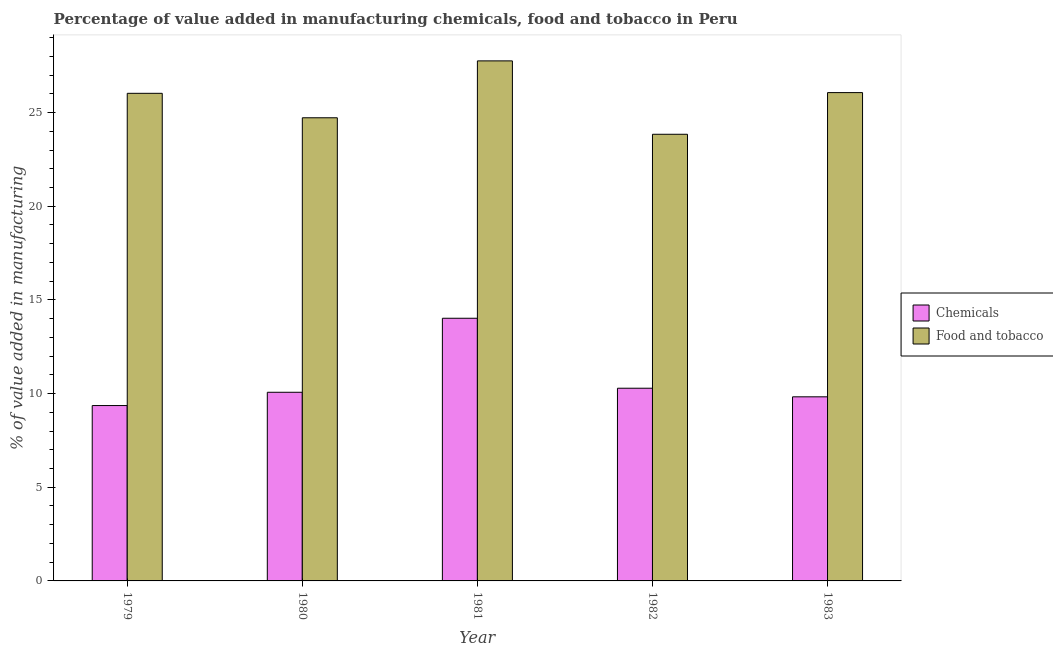How many different coloured bars are there?
Offer a very short reply. 2. How many groups of bars are there?
Offer a terse response. 5. Are the number of bars per tick equal to the number of legend labels?
Your answer should be very brief. Yes. How many bars are there on the 4th tick from the left?
Ensure brevity in your answer.  2. How many bars are there on the 5th tick from the right?
Offer a very short reply. 2. In how many cases, is the number of bars for a given year not equal to the number of legend labels?
Make the answer very short. 0. What is the value added by manufacturing food and tobacco in 1982?
Provide a short and direct response. 23.84. Across all years, what is the maximum value added by manufacturing food and tobacco?
Provide a short and direct response. 27.76. Across all years, what is the minimum value added by manufacturing food and tobacco?
Keep it short and to the point. 23.84. In which year was the value added by  manufacturing chemicals maximum?
Your answer should be compact. 1981. In which year was the value added by  manufacturing chemicals minimum?
Your answer should be compact. 1979. What is the total value added by manufacturing food and tobacco in the graph?
Keep it short and to the point. 128.42. What is the difference between the value added by manufacturing food and tobacco in 1980 and that in 1982?
Provide a short and direct response. 0.88. What is the difference between the value added by  manufacturing chemicals in 1982 and the value added by manufacturing food and tobacco in 1980?
Provide a succinct answer. 0.22. What is the average value added by manufacturing food and tobacco per year?
Ensure brevity in your answer.  25.68. In the year 1982, what is the difference between the value added by manufacturing food and tobacco and value added by  manufacturing chemicals?
Make the answer very short. 0. What is the ratio of the value added by manufacturing food and tobacco in 1979 to that in 1981?
Make the answer very short. 0.94. Is the value added by manufacturing food and tobacco in 1982 less than that in 1983?
Give a very brief answer. Yes. Is the difference between the value added by manufacturing food and tobacco in 1980 and 1981 greater than the difference between the value added by  manufacturing chemicals in 1980 and 1981?
Your answer should be compact. No. What is the difference between the highest and the second highest value added by  manufacturing chemicals?
Your response must be concise. 3.73. What is the difference between the highest and the lowest value added by  manufacturing chemicals?
Offer a terse response. 4.66. In how many years, is the value added by  manufacturing chemicals greater than the average value added by  manufacturing chemicals taken over all years?
Your answer should be very brief. 1. What does the 2nd bar from the left in 1981 represents?
Provide a succinct answer. Food and tobacco. What does the 1st bar from the right in 1981 represents?
Offer a very short reply. Food and tobacco. How many bars are there?
Give a very brief answer. 10. How many years are there in the graph?
Make the answer very short. 5. Are the values on the major ticks of Y-axis written in scientific E-notation?
Offer a terse response. No. Does the graph contain any zero values?
Provide a succinct answer. No. Where does the legend appear in the graph?
Your answer should be compact. Center right. How many legend labels are there?
Offer a terse response. 2. How are the legend labels stacked?
Offer a very short reply. Vertical. What is the title of the graph?
Give a very brief answer. Percentage of value added in manufacturing chemicals, food and tobacco in Peru. What is the label or title of the Y-axis?
Provide a succinct answer. % of value added in manufacturing. What is the % of value added in manufacturing in Chemicals in 1979?
Your answer should be compact. 9.36. What is the % of value added in manufacturing in Food and tobacco in 1979?
Ensure brevity in your answer.  26.03. What is the % of value added in manufacturing in Chemicals in 1980?
Your answer should be very brief. 10.07. What is the % of value added in manufacturing in Food and tobacco in 1980?
Keep it short and to the point. 24.72. What is the % of value added in manufacturing in Chemicals in 1981?
Make the answer very short. 14.02. What is the % of value added in manufacturing of Food and tobacco in 1981?
Your answer should be compact. 27.76. What is the % of value added in manufacturing in Chemicals in 1982?
Keep it short and to the point. 10.29. What is the % of value added in manufacturing of Food and tobacco in 1982?
Provide a short and direct response. 23.84. What is the % of value added in manufacturing in Chemicals in 1983?
Offer a very short reply. 9.83. What is the % of value added in manufacturing in Food and tobacco in 1983?
Provide a succinct answer. 26.07. Across all years, what is the maximum % of value added in manufacturing in Chemicals?
Ensure brevity in your answer.  14.02. Across all years, what is the maximum % of value added in manufacturing in Food and tobacco?
Offer a very short reply. 27.76. Across all years, what is the minimum % of value added in manufacturing in Chemicals?
Offer a very short reply. 9.36. Across all years, what is the minimum % of value added in manufacturing in Food and tobacco?
Your answer should be compact. 23.84. What is the total % of value added in manufacturing of Chemicals in the graph?
Provide a short and direct response. 53.56. What is the total % of value added in manufacturing of Food and tobacco in the graph?
Keep it short and to the point. 128.42. What is the difference between the % of value added in manufacturing in Chemicals in 1979 and that in 1980?
Offer a very short reply. -0.71. What is the difference between the % of value added in manufacturing of Food and tobacco in 1979 and that in 1980?
Give a very brief answer. 1.31. What is the difference between the % of value added in manufacturing of Chemicals in 1979 and that in 1981?
Ensure brevity in your answer.  -4.66. What is the difference between the % of value added in manufacturing in Food and tobacco in 1979 and that in 1981?
Provide a short and direct response. -1.73. What is the difference between the % of value added in manufacturing of Chemicals in 1979 and that in 1982?
Provide a short and direct response. -0.93. What is the difference between the % of value added in manufacturing in Food and tobacco in 1979 and that in 1982?
Give a very brief answer. 2.19. What is the difference between the % of value added in manufacturing in Chemicals in 1979 and that in 1983?
Your answer should be very brief. -0.47. What is the difference between the % of value added in manufacturing in Food and tobacco in 1979 and that in 1983?
Your answer should be compact. -0.04. What is the difference between the % of value added in manufacturing of Chemicals in 1980 and that in 1981?
Ensure brevity in your answer.  -3.95. What is the difference between the % of value added in manufacturing in Food and tobacco in 1980 and that in 1981?
Provide a short and direct response. -3.04. What is the difference between the % of value added in manufacturing of Chemicals in 1980 and that in 1982?
Your answer should be compact. -0.22. What is the difference between the % of value added in manufacturing in Food and tobacco in 1980 and that in 1982?
Provide a succinct answer. 0.88. What is the difference between the % of value added in manufacturing of Chemicals in 1980 and that in 1983?
Offer a terse response. 0.24. What is the difference between the % of value added in manufacturing in Food and tobacco in 1980 and that in 1983?
Your response must be concise. -1.34. What is the difference between the % of value added in manufacturing of Chemicals in 1981 and that in 1982?
Offer a terse response. 3.73. What is the difference between the % of value added in manufacturing in Food and tobacco in 1981 and that in 1982?
Offer a very short reply. 3.92. What is the difference between the % of value added in manufacturing in Chemicals in 1981 and that in 1983?
Ensure brevity in your answer.  4.19. What is the difference between the % of value added in manufacturing in Food and tobacco in 1981 and that in 1983?
Keep it short and to the point. 1.69. What is the difference between the % of value added in manufacturing in Chemicals in 1982 and that in 1983?
Provide a succinct answer. 0.46. What is the difference between the % of value added in manufacturing in Food and tobacco in 1982 and that in 1983?
Provide a short and direct response. -2.22. What is the difference between the % of value added in manufacturing of Chemicals in 1979 and the % of value added in manufacturing of Food and tobacco in 1980?
Your response must be concise. -15.36. What is the difference between the % of value added in manufacturing of Chemicals in 1979 and the % of value added in manufacturing of Food and tobacco in 1981?
Offer a terse response. -18.4. What is the difference between the % of value added in manufacturing of Chemicals in 1979 and the % of value added in manufacturing of Food and tobacco in 1982?
Your answer should be very brief. -14.48. What is the difference between the % of value added in manufacturing in Chemicals in 1979 and the % of value added in manufacturing in Food and tobacco in 1983?
Offer a very short reply. -16.71. What is the difference between the % of value added in manufacturing in Chemicals in 1980 and the % of value added in manufacturing in Food and tobacco in 1981?
Ensure brevity in your answer.  -17.69. What is the difference between the % of value added in manufacturing of Chemicals in 1980 and the % of value added in manufacturing of Food and tobacco in 1982?
Your answer should be compact. -13.77. What is the difference between the % of value added in manufacturing of Chemicals in 1980 and the % of value added in manufacturing of Food and tobacco in 1983?
Your response must be concise. -16. What is the difference between the % of value added in manufacturing of Chemicals in 1981 and the % of value added in manufacturing of Food and tobacco in 1982?
Provide a succinct answer. -9.82. What is the difference between the % of value added in manufacturing in Chemicals in 1981 and the % of value added in manufacturing in Food and tobacco in 1983?
Provide a succinct answer. -12.05. What is the difference between the % of value added in manufacturing of Chemicals in 1982 and the % of value added in manufacturing of Food and tobacco in 1983?
Give a very brief answer. -15.78. What is the average % of value added in manufacturing of Chemicals per year?
Offer a very short reply. 10.71. What is the average % of value added in manufacturing of Food and tobacco per year?
Your answer should be compact. 25.68. In the year 1979, what is the difference between the % of value added in manufacturing of Chemicals and % of value added in manufacturing of Food and tobacco?
Your response must be concise. -16.67. In the year 1980, what is the difference between the % of value added in manufacturing of Chemicals and % of value added in manufacturing of Food and tobacco?
Your response must be concise. -14.65. In the year 1981, what is the difference between the % of value added in manufacturing in Chemicals and % of value added in manufacturing in Food and tobacco?
Keep it short and to the point. -13.74. In the year 1982, what is the difference between the % of value added in manufacturing of Chemicals and % of value added in manufacturing of Food and tobacco?
Your answer should be very brief. -13.56. In the year 1983, what is the difference between the % of value added in manufacturing of Chemicals and % of value added in manufacturing of Food and tobacco?
Make the answer very short. -16.24. What is the ratio of the % of value added in manufacturing in Chemicals in 1979 to that in 1980?
Make the answer very short. 0.93. What is the ratio of the % of value added in manufacturing of Food and tobacco in 1979 to that in 1980?
Offer a terse response. 1.05. What is the ratio of the % of value added in manufacturing of Chemicals in 1979 to that in 1981?
Offer a very short reply. 0.67. What is the ratio of the % of value added in manufacturing of Food and tobacco in 1979 to that in 1981?
Provide a succinct answer. 0.94. What is the ratio of the % of value added in manufacturing in Chemicals in 1979 to that in 1982?
Offer a terse response. 0.91. What is the ratio of the % of value added in manufacturing in Food and tobacco in 1979 to that in 1982?
Give a very brief answer. 1.09. What is the ratio of the % of value added in manufacturing of Chemicals in 1979 to that in 1983?
Give a very brief answer. 0.95. What is the ratio of the % of value added in manufacturing in Food and tobacco in 1979 to that in 1983?
Offer a very short reply. 1. What is the ratio of the % of value added in manufacturing of Chemicals in 1980 to that in 1981?
Offer a terse response. 0.72. What is the ratio of the % of value added in manufacturing in Food and tobacco in 1980 to that in 1981?
Make the answer very short. 0.89. What is the ratio of the % of value added in manufacturing in Food and tobacco in 1980 to that in 1982?
Provide a succinct answer. 1.04. What is the ratio of the % of value added in manufacturing of Chemicals in 1980 to that in 1983?
Provide a short and direct response. 1.02. What is the ratio of the % of value added in manufacturing of Food and tobacco in 1980 to that in 1983?
Your response must be concise. 0.95. What is the ratio of the % of value added in manufacturing in Chemicals in 1981 to that in 1982?
Your answer should be very brief. 1.36. What is the ratio of the % of value added in manufacturing in Food and tobacco in 1981 to that in 1982?
Keep it short and to the point. 1.16. What is the ratio of the % of value added in manufacturing in Chemicals in 1981 to that in 1983?
Offer a terse response. 1.43. What is the ratio of the % of value added in manufacturing of Food and tobacco in 1981 to that in 1983?
Make the answer very short. 1.06. What is the ratio of the % of value added in manufacturing of Chemicals in 1982 to that in 1983?
Provide a succinct answer. 1.05. What is the ratio of the % of value added in manufacturing in Food and tobacco in 1982 to that in 1983?
Your response must be concise. 0.91. What is the difference between the highest and the second highest % of value added in manufacturing in Chemicals?
Keep it short and to the point. 3.73. What is the difference between the highest and the second highest % of value added in manufacturing in Food and tobacco?
Keep it short and to the point. 1.69. What is the difference between the highest and the lowest % of value added in manufacturing of Chemicals?
Provide a succinct answer. 4.66. What is the difference between the highest and the lowest % of value added in manufacturing of Food and tobacco?
Offer a very short reply. 3.92. 